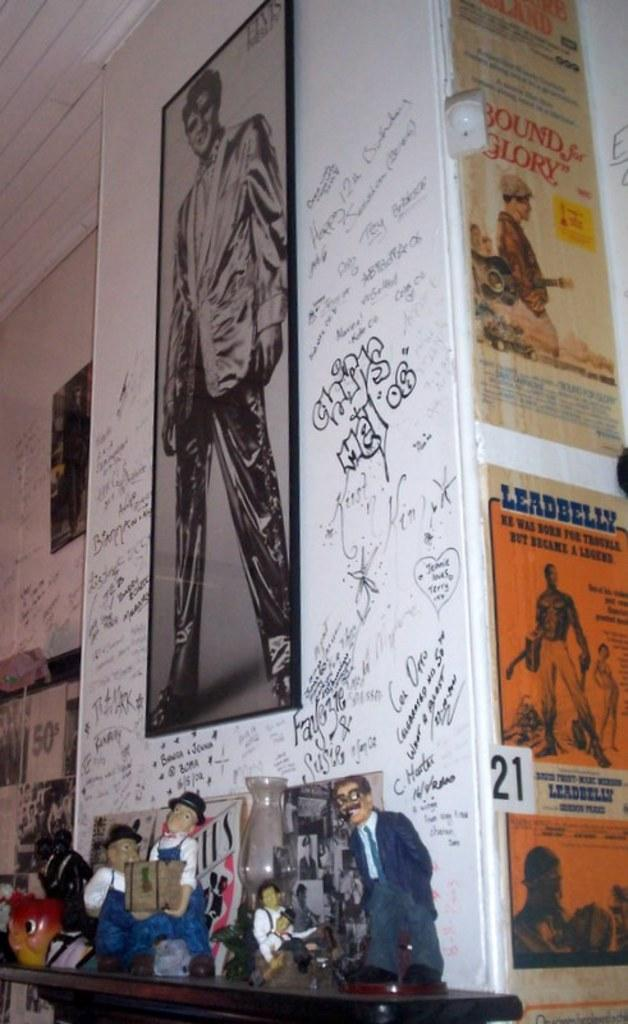<image>
Render a clear and concise summary of the photo. A fireplace mantle with dolls on it and graffiti on the wall and a poster for Bound for Glory. 